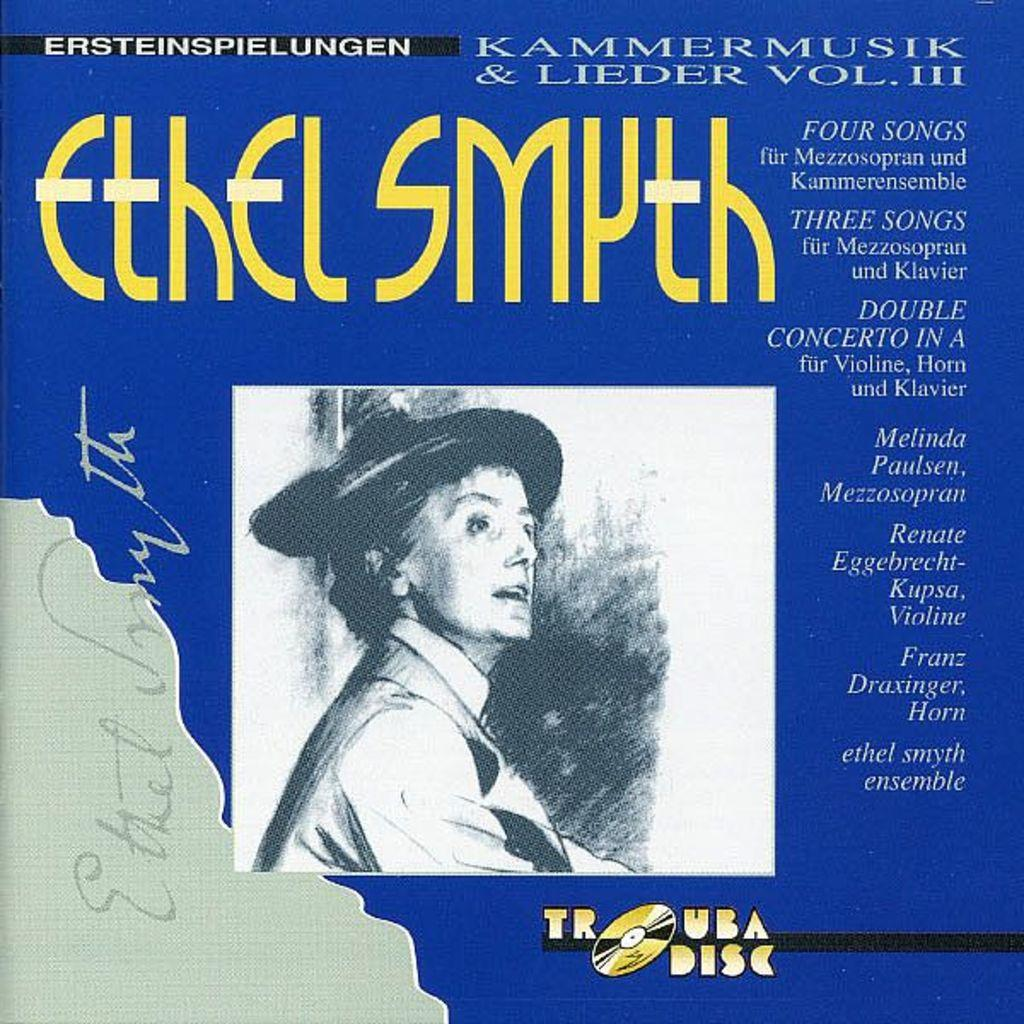What is the main subject of the image? The main subject of the image is a book cover. What is depicted on the book cover? There is a picture of a man on the book cover. Are there any words or letters on the book cover? Yes, there is text on the book cover. What type of instrument is the bear playing on the book cover? There is no bear or instrument present on the book cover; it features a picture of a man. 